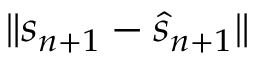<formula> <loc_0><loc_0><loc_500><loc_500>\| s _ { n + 1 } - \hat { s } _ { n + 1 } \|</formula> 